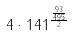Convert formula to latex. <formula><loc_0><loc_0><loc_500><loc_500>4 \cdot 1 4 1 ^ { \frac { \frac { 9 3 } { 4 9 5 } } { 2 } }</formula> 